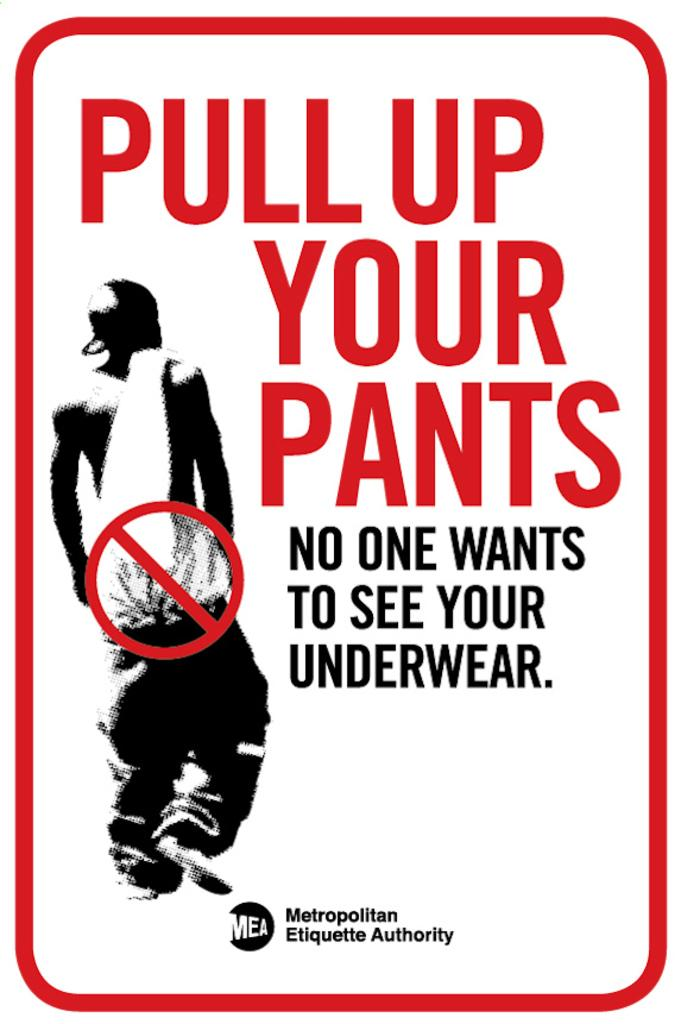<image>
Write a terse but informative summary of the picture. sign that says Pull up your pants no one wants to see your underwear. 